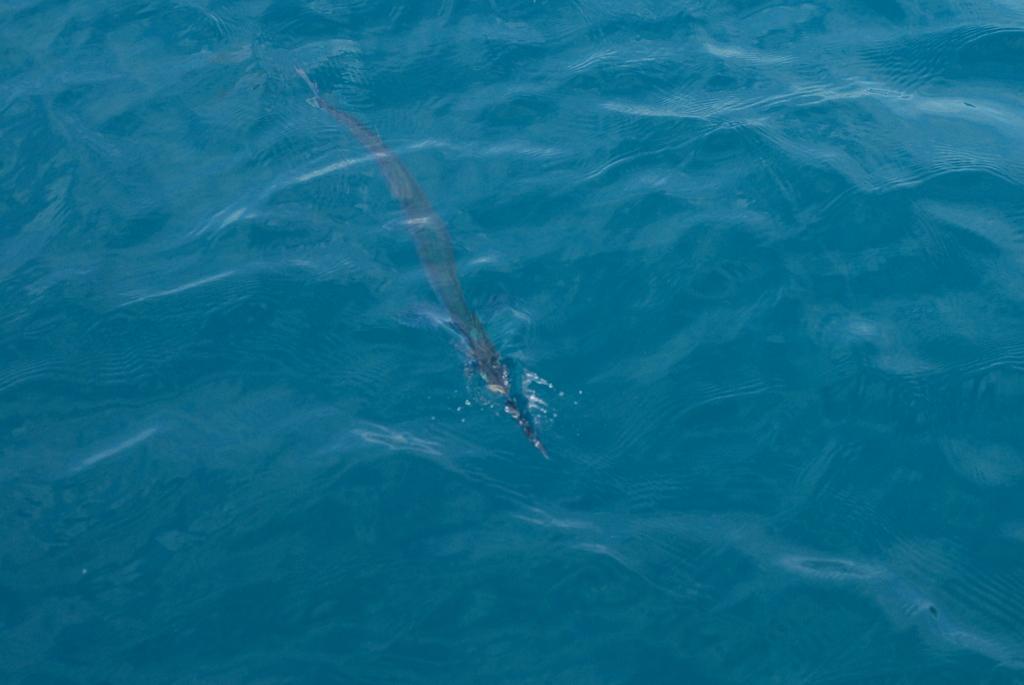How would you summarize this image in a sentence or two? In this image there is water with a water animal in it. 